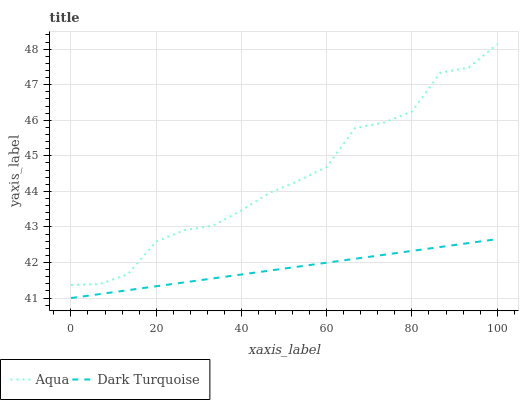Does Dark Turquoise have the minimum area under the curve?
Answer yes or no. Yes. Does Aqua have the maximum area under the curve?
Answer yes or no. Yes. Does Aqua have the minimum area under the curve?
Answer yes or no. No. Is Dark Turquoise the smoothest?
Answer yes or no. Yes. Is Aqua the roughest?
Answer yes or no. Yes. Is Aqua the smoothest?
Answer yes or no. No. Does Dark Turquoise have the lowest value?
Answer yes or no. Yes. Does Aqua have the lowest value?
Answer yes or no. No. Does Aqua have the highest value?
Answer yes or no. Yes. Is Dark Turquoise less than Aqua?
Answer yes or no. Yes. Is Aqua greater than Dark Turquoise?
Answer yes or no. Yes. Does Dark Turquoise intersect Aqua?
Answer yes or no. No. 